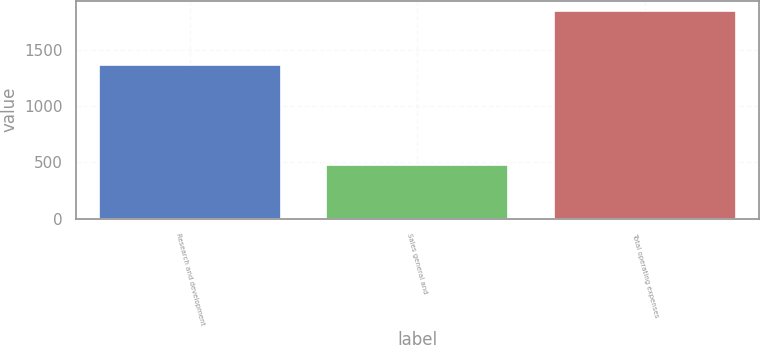Convert chart. <chart><loc_0><loc_0><loc_500><loc_500><bar_chart><fcel>Research and development<fcel>Sales general and<fcel>Total operating expenses<nl><fcel>1359.7<fcel>480.8<fcel>1840.5<nl></chart> 